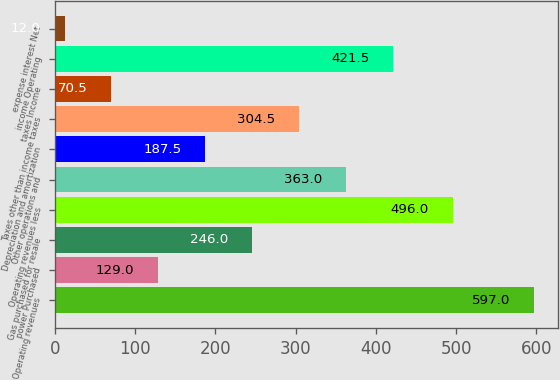Convert chart to OTSL. <chart><loc_0><loc_0><loc_500><loc_500><bar_chart><fcel>Operating revenues<fcel>power Purchased<fcel>Gas purchased for resale<fcel>Operating revenues less<fcel>Other operations and<fcel>Depreciation and amortization<fcel>Taxes other than income taxes<fcel>taxes Income<fcel>income Operating<fcel>expense interest Net<nl><fcel>597<fcel>129<fcel>246<fcel>496<fcel>363<fcel>187.5<fcel>304.5<fcel>70.5<fcel>421.5<fcel>12<nl></chart> 